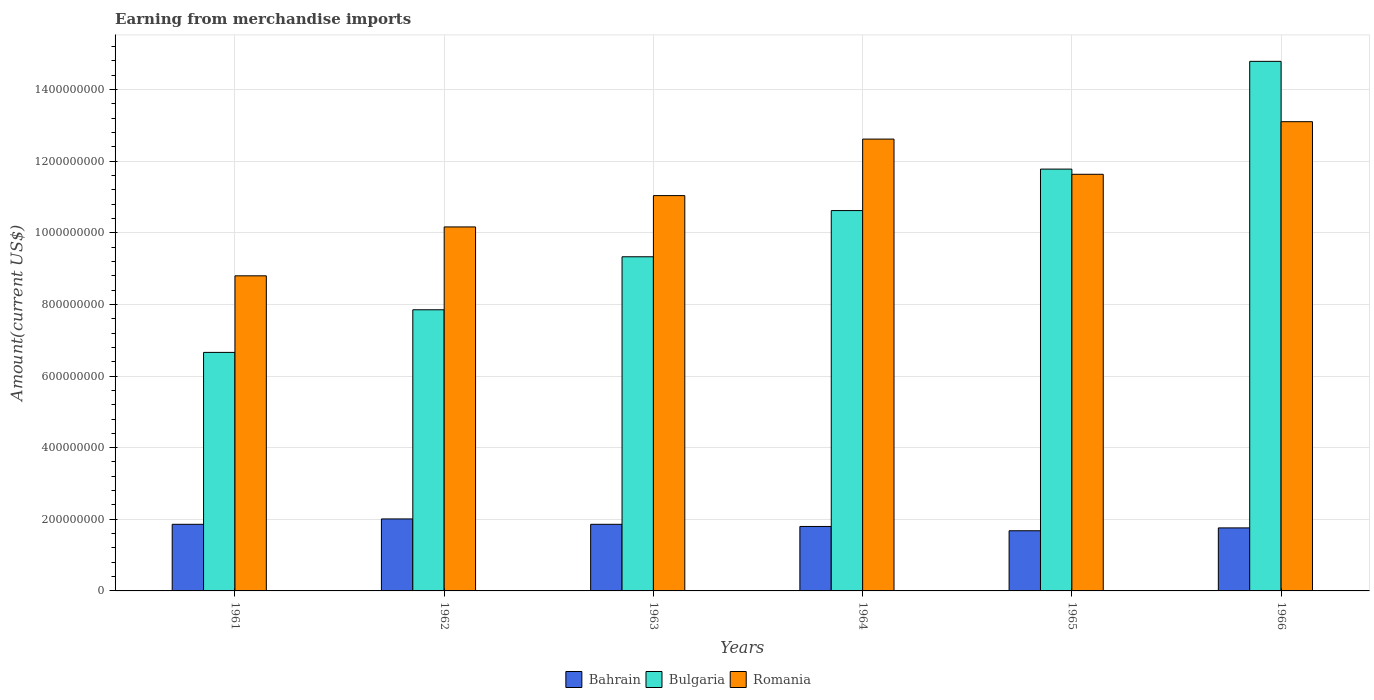Are the number of bars per tick equal to the number of legend labels?
Your answer should be very brief. Yes. Are the number of bars on each tick of the X-axis equal?
Your answer should be very brief. Yes. How many bars are there on the 4th tick from the right?
Provide a short and direct response. 3. What is the label of the 5th group of bars from the left?
Your response must be concise. 1965. In how many cases, is the number of bars for a given year not equal to the number of legend labels?
Your answer should be very brief. 0. What is the amount earned from merchandise imports in Romania in 1961?
Make the answer very short. 8.80e+08. Across all years, what is the maximum amount earned from merchandise imports in Bulgaria?
Your answer should be very brief. 1.48e+09. Across all years, what is the minimum amount earned from merchandise imports in Bulgaria?
Give a very brief answer. 6.66e+08. In which year was the amount earned from merchandise imports in Bulgaria maximum?
Keep it short and to the point. 1966. In which year was the amount earned from merchandise imports in Romania minimum?
Give a very brief answer. 1961. What is the total amount earned from merchandise imports in Romania in the graph?
Keep it short and to the point. 6.74e+09. What is the difference between the amount earned from merchandise imports in Romania in 1962 and that in 1965?
Give a very brief answer. -1.47e+08. What is the difference between the amount earned from merchandise imports in Bulgaria in 1966 and the amount earned from merchandise imports in Bahrain in 1963?
Your response must be concise. 1.29e+09. What is the average amount earned from merchandise imports in Romania per year?
Your answer should be compact. 1.12e+09. In the year 1964, what is the difference between the amount earned from merchandise imports in Bahrain and amount earned from merchandise imports in Bulgaria?
Your answer should be very brief. -8.82e+08. In how many years, is the amount earned from merchandise imports in Romania greater than 1480000000 US$?
Provide a short and direct response. 0. What is the ratio of the amount earned from merchandise imports in Bahrain in 1963 to that in 1965?
Make the answer very short. 1.11. What is the difference between the highest and the second highest amount earned from merchandise imports in Bahrain?
Provide a succinct answer. 1.50e+07. What is the difference between the highest and the lowest amount earned from merchandise imports in Bulgaria?
Provide a short and direct response. 8.13e+08. In how many years, is the amount earned from merchandise imports in Romania greater than the average amount earned from merchandise imports in Romania taken over all years?
Provide a succinct answer. 3. What does the 1st bar from the left in 1965 represents?
Make the answer very short. Bahrain. What does the 1st bar from the right in 1966 represents?
Offer a very short reply. Romania. Is it the case that in every year, the sum of the amount earned from merchandise imports in Bahrain and amount earned from merchandise imports in Bulgaria is greater than the amount earned from merchandise imports in Romania?
Keep it short and to the point. No. How many bars are there?
Your answer should be very brief. 18. Are all the bars in the graph horizontal?
Your answer should be compact. No. Are the values on the major ticks of Y-axis written in scientific E-notation?
Keep it short and to the point. No. Where does the legend appear in the graph?
Ensure brevity in your answer.  Bottom center. What is the title of the graph?
Offer a very short reply. Earning from merchandise imports. Does "India" appear as one of the legend labels in the graph?
Provide a succinct answer. No. What is the label or title of the Y-axis?
Offer a very short reply. Amount(current US$). What is the Amount(current US$) of Bahrain in 1961?
Offer a terse response. 1.86e+08. What is the Amount(current US$) of Bulgaria in 1961?
Provide a succinct answer. 6.66e+08. What is the Amount(current US$) in Romania in 1961?
Offer a very short reply. 8.80e+08. What is the Amount(current US$) in Bahrain in 1962?
Provide a succinct answer. 2.01e+08. What is the Amount(current US$) of Bulgaria in 1962?
Provide a succinct answer. 7.85e+08. What is the Amount(current US$) of Romania in 1962?
Make the answer very short. 1.02e+09. What is the Amount(current US$) in Bahrain in 1963?
Your answer should be very brief. 1.86e+08. What is the Amount(current US$) of Bulgaria in 1963?
Provide a succinct answer. 9.33e+08. What is the Amount(current US$) in Romania in 1963?
Offer a very short reply. 1.10e+09. What is the Amount(current US$) of Bahrain in 1964?
Your response must be concise. 1.80e+08. What is the Amount(current US$) in Bulgaria in 1964?
Your answer should be very brief. 1.06e+09. What is the Amount(current US$) in Romania in 1964?
Offer a very short reply. 1.26e+09. What is the Amount(current US$) in Bahrain in 1965?
Provide a short and direct response. 1.68e+08. What is the Amount(current US$) in Bulgaria in 1965?
Provide a short and direct response. 1.18e+09. What is the Amount(current US$) in Romania in 1965?
Offer a terse response. 1.16e+09. What is the Amount(current US$) of Bahrain in 1966?
Provide a succinct answer. 1.76e+08. What is the Amount(current US$) in Bulgaria in 1966?
Offer a terse response. 1.48e+09. What is the Amount(current US$) in Romania in 1966?
Give a very brief answer. 1.31e+09. Across all years, what is the maximum Amount(current US$) in Bahrain?
Your response must be concise. 2.01e+08. Across all years, what is the maximum Amount(current US$) of Bulgaria?
Your answer should be compact. 1.48e+09. Across all years, what is the maximum Amount(current US$) in Romania?
Provide a short and direct response. 1.31e+09. Across all years, what is the minimum Amount(current US$) in Bahrain?
Ensure brevity in your answer.  1.68e+08. Across all years, what is the minimum Amount(current US$) of Bulgaria?
Your response must be concise. 6.66e+08. Across all years, what is the minimum Amount(current US$) of Romania?
Provide a succinct answer. 8.80e+08. What is the total Amount(current US$) of Bahrain in the graph?
Make the answer very short. 1.10e+09. What is the total Amount(current US$) of Bulgaria in the graph?
Provide a short and direct response. 6.10e+09. What is the total Amount(current US$) in Romania in the graph?
Offer a very short reply. 6.74e+09. What is the difference between the Amount(current US$) in Bahrain in 1961 and that in 1962?
Your response must be concise. -1.50e+07. What is the difference between the Amount(current US$) of Bulgaria in 1961 and that in 1962?
Make the answer very short. -1.19e+08. What is the difference between the Amount(current US$) of Romania in 1961 and that in 1962?
Offer a very short reply. -1.36e+08. What is the difference between the Amount(current US$) in Bahrain in 1961 and that in 1963?
Your answer should be very brief. 0. What is the difference between the Amount(current US$) in Bulgaria in 1961 and that in 1963?
Offer a very short reply. -2.67e+08. What is the difference between the Amount(current US$) in Romania in 1961 and that in 1963?
Keep it short and to the point. -2.24e+08. What is the difference between the Amount(current US$) in Bulgaria in 1961 and that in 1964?
Make the answer very short. -3.96e+08. What is the difference between the Amount(current US$) in Romania in 1961 and that in 1964?
Keep it short and to the point. -3.82e+08. What is the difference between the Amount(current US$) of Bahrain in 1961 and that in 1965?
Ensure brevity in your answer.  1.80e+07. What is the difference between the Amount(current US$) of Bulgaria in 1961 and that in 1965?
Provide a short and direct response. -5.12e+08. What is the difference between the Amount(current US$) of Romania in 1961 and that in 1965?
Make the answer very short. -2.84e+08. What is the difference between the Amount(current US$) of Bahrain in 1961 and that in 1966?
Provide a succinct answer. 1.00e+07. What is the difference between the Amount(current US$) in Bulgaria in 1961 and that in 1966?
Provide a succinct answer. -8.13e+08. What is the difference between the Amount(current US$) of Romania in 1961 and that in 1966?
Ensure brevity in your answer.  -4.30e+08. What is the difference between the Amount(current US$) in Bahrain in 1962 and that in 1963?
Your answer should be very brief. 1.50e+07. What is the difference between the Amount(current US$) of Bulgaria in 1962 and that in 1963?
Your answer should be very brief. -1.48e+08. What is the difference between the Amount(current US$) in Romania in 1962 and that in 1963?
Offer a very short reply. -8.75e+07. What is the difference between the Amount(current US$) of Bahrain in 1962 and that in 1964?
Give a very brief answer. 2.10e+07. What is the difference between the Amount(current US$) in Bulgaria in 1962 and that in 1964?
Your answer should be very brief. -2.77e+08. What is the difference between the Amount(current US$) of Romania in 1962 and that in 1964?
Offer a very short reply. -2.45e+08. What is the difference between the Amount(current US$) of Bahrain in 1962 and that in 1965?
Offer a terse response. 3.30e+07. What is the difference between the Amount(current US$) in Bulgaria in 1962 and that in 1965?
Your answer should be very brief. -3.93e+08. What is the difference between the Amount(current US$) of Romania in 1962 and that in 1965?
Provide a short and direct response. -1.47e+08. What is the difference between the Amount(current US$) in Bahrain in 1962 and that in 1966?
Provide a short and direct response. 2.50e+07. What is the difference between the Amount(current US$) in Bulgaria in 1962 and that in 1966?
Make the answer very short. -6.94e+08. What is the difference between the Amount(current US$) in Romania in 1962 and that in 1966?
Ensure brevity in your answer.  -2.94e+08. What is the difference between the Amount(current US$) of Bahrain in 1963 and that in 1964?
Provide a succinct answer. 6.00e+06. What is the difference between the Amount(current US$) in Bulgaria in 1963 and that in 1964?
Offer a very short reply. -1.29e+08. What is the difference between the Amount(current US$) in Romania in 1963 and that in 1964?
Offer a terse response. -1.58e+08. What is the difference between the Amount(current US$) in Bahrain in 1963 and that in 1965?
Your answer should be compact. 1.80e+07. What is the difference between the Amount(current US$) of Bulgaria in 1963 and that in 1965?
Keep it short and to the point. -2.45e+08. What is the difference between the Amount(current US$) of Romania in 1963 and that in 1965?
Provide a short and direct response. -5.95e+07. What is the difference between the Amount(current US$) in Bahrain in 1963 and that in 1966?
Offer a terse response. 1.00e+07. What is the difference between the Amount(current US$) in Bulgaria in 1963 and that in 1966?
Offer a very short reply. -5.46e+08. What is the difference between the Amount(current US$) of Romania in 1963 and that in 1966?
Make the answer very short. -2.06e+08. What is the difference between the Amount(current US$) of Bulgaria in 1964 and that in 1965?
Give a very brief answer. -1.16e+08. What is the difference between the Amount(current US$) of Romania in 1964 and that in 1965?
Your response must be concise. 9.83e+07. What is the difference between the Amount(current US$) of Bahrain in 1964 and that in 1966?
Offer a terse response. 4.02e+06. What is the difference between the Amount(current US$) in Bulgaria in 1964 and that in 1966?
Your answer should be very brief. -4.17e+08. What is the difference between the Amount(current US$) of Romania in 1964 and that in 1966?
Ensure brevity in your answer.  -4.86e+07. What is the difference between the Amount(current US$) of Bahrain in 1965 and that in 1966?
Provide a short and direct response. -7.98e+06. What is the difference between the Amount(current US$) in Bulgaria in 1965 and that in 1966?
Ensure brevity in your answer.  -3.01e+08. What is the difference between the Amount(current US$) of Romania in 1965 and that in 1966?
Your answer should be compact. -1.47e+08. What is the difference between the Amount(current US$) of Bahrain in 1961 and the Amount(current US$) of Bulgaria in 1962?
Offer a very short reply. -5.99e+08. What is the difference between the Amount(current US$) of Bahrain in 1961 and the Amount(current US$) of Romania in 1962?
Make the answer very short. -8.30e+08. What is the difference between the Amount(current US$) in Bulgaria in 1961 and the Amount(current US$) in Romania in 1962?
Keep it short and to the point. -3.50e+08. What is the difference between the Amount(current US$) in Bahrain in 1961 and the Amount(current US$) in Bulgaria in 1963?
Your answer should be very brief. -7.47e+08. What is the difference between the Amount(current US$) of Bahrain in 1961 and the Amount(current US$) of Romania in 1963?
Make the answer very short. -9.18e+08. What is the difference between the Amount(current US$) in Bulgaria in 1961 and the Amount(current US$) in Romania in 1963?
Give a very brief answer. -4.38e+08. What is the difference between the Amount(current US$) of Bahrain in 1961 and the Amount(current US$) of Bulgaria in 1964?
Your answer should be compact. -8.76e+08. What is the difference between the Amount(current US$) in Bahrain in 1961 and the Amount(current US$) in Romania in 1964?
Offer a very short reply. -1.08e+09. What is the difference between the Amount(current US$) in Bulgaria in 1961 and the Amount(current US$) in Romania in 1964?
Provide a short and direct response. -5.96e+08. What is the difference between the Amount(current US$) of Bahrain in 1961 and the Amount(current US$) of Bulgaria in 1965?
Ensure brevity in your answer.  -9.92e+08. What is the difference between the Amount(current US$) of Bahrain in 1961 and the Amount(current US$) of Romania in 1965?
Provide a succinct answer. -9.77e+08. What is the difference between the Amount(current US$) in Bulgaria in 1961 and the Amount(current US$) in Romania in 1965?
Keep it short and to the point. -4.97e+08. What is the difference between the Amount(current US$) of Bahrain in 1961 and the Amount(current US$) of Bulgaria in 1966?
Give a very brief answer. -1.29e+09. What is the difference between the Amount(current US$) in Bahrain in 1961 and the Amount(current US$) in Romania in 1966?
Ensure brevity in your answer.  -1.12e+09. What is the difference between the Amount(current US$) in Bulgaria in 1961 and the Amount(current US$) in Romania in 1966?
Provide a short and direct response. -6.44e+08. What is the difference between the Amount(current US$) of Bahrain in 1962 and the Amount(current US$) of Bulgaria in 1963?
Keep it short and to the point. -7.32e+08. What is the difference between the Amount(current US$) in Bahrain in 1962 and the Amount(current US$) in Romania in 1963?
Keep it short and to the point. -9.03e+08. What is the difference between the Amount(current US$) in Bulgaria in 1962 and the Amount(current US$) in Romania in 1963?
Offer a terse response. -3.19e+08. What is the difference between the Amount(current US$) in Bahrain in 1962 and the Amount(current US$) in Bulgaria in 1964?
Give a very brief answer. -8.61e+08. What is the difference between the Amount(current US$) in Bahrain in 1962 and the Amount(current US$) in Romania in 1964?
Your answer should be very brief. -1.06e+09. What is the difference between the Amount(current US$) in Bulgaria in 1962 and the Amount(current US$) in Romania in 1964?
Your answer should be compact. -4.77e+08. What is the difference between the Amount(current US$) of Bahrain in 1962 and the Amount(current US$) of Bulgaria in 1965?
Your response must be concise. -9.77e+08. What is the difference between the Amount(current US$) in Bahrain in 1962 and the Amount(current US$) in Romania in 1965?
Give a very brief answer. -9.62e+08. What is the difference between the Amount(current US$) in Bulgaria in 1962 and the Amount(current US$) in Romania in 1965?
Provide a succinct answer. -3.78e+08. What is the difference between the Amount(current US$) of Bahrain in 1962 and the Amount(current US$) of Bulgaria in 1966?
Your answer should be very brief. -1.28e+09. What is the difference between the Amount(current US$) in Bahrain in 1962 and the Amount(current US$) in Romania in 1966?
Make the answer very short. -1.11e+09. What is the difference between the Amount(current US$) in Bulgaria in 1962 and the Amount(current US$) in Romania in 1966?
Ensure brevity in your answer.  -5.25e+08. What is the difference between the Amount(current US$) in Bahrain in 1963 and the Amount(current US$) in Bulgaria in 1964?
Your response must be concise. -8.76e+08. What is the difference between the Amount(current US$) in Bahrain in 1963 and the Amount(current US$) in Romania in 1964?
Your answer should be compact. -1.08e+09. What is the difference between the Amount(current US$) in Bulgaria in 1963 and the Amount(current US$) in Romania in 1964?
Your answer should be very brief. -3.29e+08. What is the difference between the Amount(current US$) in Bahrain in 1963 and the Amount(current US$) in Bulgaria in 1965?
Offer a very short reply. -9.92e+08. What is the difference between the Amount(current US$) of Bahrain in 1963 and the Amount(current US$) of Romania in 1965?
Offer a terse response. -9.77e+08. What is the difference between the Amount(current US$) in Bulgaria in 1963 and the Amount(current US$) in Romania in 1965?
Offer a very short reply. -2.30e+08. What is the difference between the Amount(current US$) of Bahrain in 1963 and the Amount(current US$) of Bulgaria in 1966?
Ensure brevity in your answer.  -1.29e+09. What is the difference between the Amount(current US$) of Bahrain in 1963 and the Amount(current US$) of Romania in 1966?
Your response must be concise. -1.12e+09. What is the difference between the Amount(current US$) of Bulgaria in 1963 and the Amount(current US$) of Romania in 1966?
Keep it short and to the point. -3.77e+08. What is the difference between the Amount(current US$) of Bahrain in 1964 and the Amount(current US$) of Bulgaria in 1965?
Give a very brief answer. -9.98e+08. What is the difference between the Amount(current US$) in Bahrain in 1964 and the Amount(current US$) in Romania in 1965?
Your answer should be compact. -9.83e+08. What is the difference between the Amount(current US$) in Bulgaria in 1964 and the Amount(current US$) in Romania in 1965?
Ensure brevity in your answer.  -1.01e+08. What is the difference between the Amount(current US$) of Bahrain in 1964 and the Amount(current US$) of Bulgaria in 1966?
Offer a terse response. -1.30e+09. What is the difference between the Amount(current US$) of Bahrain in 1964 and the Amount(current US$) of Romania in 1966?
Your answer should be compact. -1.13e+09. What is the difference between the Amount(current US$) of Bulgaria in 1964 and the Amount(current US$) of Romania in 1966?
Offer a terse response. -2.48e+08. What is the difference between the Amount(current US$) in Bahrain in 1965 and the Amount(current US$) in Bulgaria in 1966?
Give a very brief answer. -1.31e+09. What is the difference between the Amount(current US$) in Bahrain in 1965 and the Amount(current US$) in Romania in 1966?
Ensure brevity in your answer.  -1.14e+09. What is the difference between the Amount(current US$) of Bulgaria in 1965 and the Amount(current US$) of Romania in 1966?
Keep it short and to the point. -1.32e+08. What is the average Amount(current US$) in Bahrain per year?
Offer a very short reply. 1.83e+08. What is the average Amount(current US$) in Bulgaria per year?
Ensure brevity in your answer.  1.02e+09. What is the average Amount(current US$) of Romania per year?
Make the answer very short. 1.12e+09. In the year 1961, what is the difference between the Amount(current US$) in Bahrain and Amount(current US$) in Bulgaria?
Your response must be concise. -4.80e+08. In the year 1961, what is the difference between the Amount(current US$) in Bahrain and Amount(current US$) in Romania?
Give a very brief answer. -6.94e+08. In the year 1961, what is the difference between the Amount(current US$) of Bulgaria and Amount(current US$) of Romania?
Provide a succinct answer. -2.14e+08. In the year 1962, what is the difference between the Amount(current US$) of Bahrain and Amount(current US$) of Bulgaria?
Keep it short and to the point. -5.84e+08. In the year 1962, what is the difference between the Amount(current US$) of Bahrain and Amount(current US$) of Romania?
Ensure brevity in your answer.  -8.15e+08. In the year 1962, what is the difference between the Amount(current US$) in Bulgaria and Amount(current US$) in Romania?
Provide a short and direct response. -2.31e+08. In the year 1963, what is the difference between the Amount(current US$) of Bahrain and Amount(current US$) of Bulgaria?
Your answer should be very brief. -7.47e+08. In the year 1963, what is the difference between the Amount(current US$) in Bahrain and Amount(current US$) in Romania?
Your answer should be very brief. -9.18e+08. In the year 1963, what is the difference between the Amount(current US$) in Bulgaria and Amount(current US$) in Romania?
Offer a terse response. -1.71e+08. In the year 1964, what is the difference between the Amount(current US$) in Bahrain and Amount(current US$) in Bulgaria?
Offer a very short reply. -8.82e+08. In the year 1964, what is the difference between the Amount(current US$) of Bahrain and Amount(current US$) of Romania?
Offer a very short reply. -1.08e+09. In the year 1964, what is the difference between the Amount(current US$) of Bulgaria and Amount(current US$) of Romania?
Offer a terse response. -2.00e+08. In the year 1965, what is the difference between the Amount(current US$) in Bahrain and Amount(current US$) in Bulgaria?
Make the answer very short. -1.01e+09. In the year 1965, what is the difference between the Amount(current US$) of Bahrain and Amount(current US$) of Romania?
Offer a terse response. -9.95e+08. In the year 1965, what is the difference between the Amount(current US$) in Bulgaria and Amount(current US$) in Romania?
Give a very brief answer. 1.45e+07. In the year 1966, what is the difference between the Amount(current US$) in Bahrain and Amount(current US$) in Bulgaria?
Your answer should be very brief. -1.30e+09. In the year 1966, what is the difference between the Amount(current US$) in Bahrain and Amount(current US$) in Romania?
Provide a succinct answer. -1.13e+09. In the year 1966, what is the difference between the Amount(current US$) in Bulgaria and Amount(current US$) in Romania?
Offer a terse response. 1.68e+08. What is the ratio of the Amount(current US$) of Bahrain in 1961 to that in 1962?
Your response must be concise. 0.93. What is the ratio of the Amount(current US$) of Bulgaria in 1961 to that in 1962?
Your response must be concise. 0.85. What is the ratio of the Amount(current US$) in Romania in 1961 to that in 1962?
Make the answer very short. 0.87. What is the ratio of the Amount(current US$) in Bahrain in 1961 to that in 1963?
Offer a very short reply. 1. What is the ratio of the Amount(current US$) in Bulgaria in 1961 to that in 1963?
Your answer should be compact. 0.71. What is the ratio of the Amount(current US$) in Romania in 1961 to that in 1963?
Your response must be concise. 0.8. What is the ratio of the Amount(current US$) in Bahrain in 1961 to that in 1964?
Your answer should be compact. 1.03. What is the ratio of the Amount(current US$) in Bulgaria in 1961 to that in 1964?
Make the answer very short. 0.63. What is the ratio of the Amount(current US$) of Romania in 1961 to that in 1964?
Offer a terse response. 0.7. What is the ratio of the Amount(current US$) in Bahrain in 1961 to that in 1965?
Your response must be concise. 1.11. What is the ratio of the Amount(current US$) in Bulgaria in 1961 to that in 1965?
Your response must be concise. 0.57. What is the ratio of the Amount(current US$) of Romania in 1961 to that in 1965?
Provide a short and direct response. 0.76. What is the ratio of the Amount(current US$) of Bahrain in 1961 to that in 1966?
Your answer should be very brief. 1.06. What is the ratio of the Amount(current US$) of Bulgaria in 1961 to that in 1966?
Make the answer very short. 0.45. What is the ratio of the Amount(current US$) of Romania in 1961 to that in 1966?
Keep it short and to the point. 0.67. What is the ratio of the Amount(current US$) in Bahrain in 1962 to that in 1963?
Offer a very short reply. 1.08. What is the ratio of the Amount(current US$) of Bulgaria in 1962 to that in 1963?
Provide a short and direct response. 0.84. What is the ratio of the Amount(current US$) of Romania in 1962 to that in 1963?
Provide a short and direct response. 0.92. What is the ratio of the Amount(current US$) of Bahrain in 1962 to that in 1964?
Provide a succinct answer. 1.12. What is the ratio of the Amount(current US$) in Bulgaria in 1962 to that in 1964?
Your answer should be compact. 0.74. What is the ratio of the Amount(current US$) of Romania in 1962 to that in 1964?
Your answer should be compact. 0.81. What is the ratio of the Amount(current US$) of Bahrain in 1962 to that in 1965?
Provide a succinct answer. 1.2. What is the ratio of the Amount(current US$) of Bulgaria in 1962 to that in 1965?
Provide a succinct answer. 0.67. What is the ratio of the Amount(current US$) of Romania in 1962 to that in 1965?
Keep it short and to the point. 0.87. What is the ratio of the Amount(current US$) in Bahrain in 1962 to that in 1966?
Ensure brevity in your answer.  1.14. What is the ratio of the Amount(current US$) in Bulgaria in 1962 to that in 1966?
Give a very brief answer. 0.53. What is the ratio of the Amount(current US$) of Romania in 1962 to that in 1966?
Ensure brevity in your answer.  0.78. What is the ratio of the Amount(current US$) in Bulgaria in 1963 to that in 1964?
Make the answer very short. 0.88. What is the ratio of the Amount(current US$) of Romania in 1963 to that in 1964?
Your response must be concise. 0.87. What is the ratio of the Amount(current US$) of Bahrain in 1963 to that in 1965?
Provide a succinct answer. 1.11. What is the ratio of the Amount(current US$) in Bulgaria in 1963 to that in 1965?
Give a very brief answer. 0.79. What is the ratio of the Amount(current US$) of Romania in 1963 to that in 1965?
Provide a succinct answer. 0.95. What is the ratio of the Amount(current US$) of Bahrain in 1963 to that in 1966?
Give a very brief answer. 1.06. What is the ratio of the Amount(current US$) of Bulgaria in 1963 to that in 1966?
Ensure brevity in your answer.  0.63. What is the ratio of the Amount(current US$) in Romania in 1963 to that in 1966?
Your response must be concise. 0.84. What is the ratio of the Amount(current US$) of Bahrain in 1964 to that in 1965?
Make the answer very short. 1.07. What is the ratio of the Amount(current US$) in Bulgaria in 1964 to that in 1965?
Offer a terse response. 0.9. What is the ratio of the Amount(current US$) in Romania in 1964 to that in 1965?
Your answer should be compact. 1.08. What is the ratio of the Amount(current US$) of Bahrain in 1964 to that in 1966?
Your response must be concise. 1.02. What is the ratio of the Amount(current US$) of Bulgaria in 1964 to that in 1966?
Your answer should be very brief. 0.72. What is the ratio of the Amount(current US$) of Romania in 1964 to that in 1966?
Provide a short and direct response. 0.96. What is the ratio of the Amount(current US$) in Bahrain in 1965 to that in 1966?
Provide a short and direct response. 0.95. What is the ratio of the Amount(current US$) of Bulgaria in 1965 to that in 1966?
Give a very brief answer. 0.8. What is the ratio of the Amount(current US$) of Romania in 1965 to that in 1966?
Offer a very short reply. 0.89. What is the difference between the highest and the second highest Amount(current US$) of Bahrain?
Offer a very short reply. 1.50e+07. What is the difference between the highest and the second highest Amount(current US$) in Bulgaria?
Make the answer very short. 3.01e+08. What is the difference between the highest and the second highest Amount(current US$) of Romania?
Make the answer very short. 4.86e+07. What is the difference between the highest and the lowest Amount(current US$) in Bahrain?
Your answer should be compact. 3.30e+07. What is the difference between the highest and the lowest Amount(current US$) of Bulgaria?
Offer a terse response. 8.13e+08. What is the difference between the highest and the lowest Amount(current US$) of Romania?
Keep it short and to the point. 4.30e+08. 